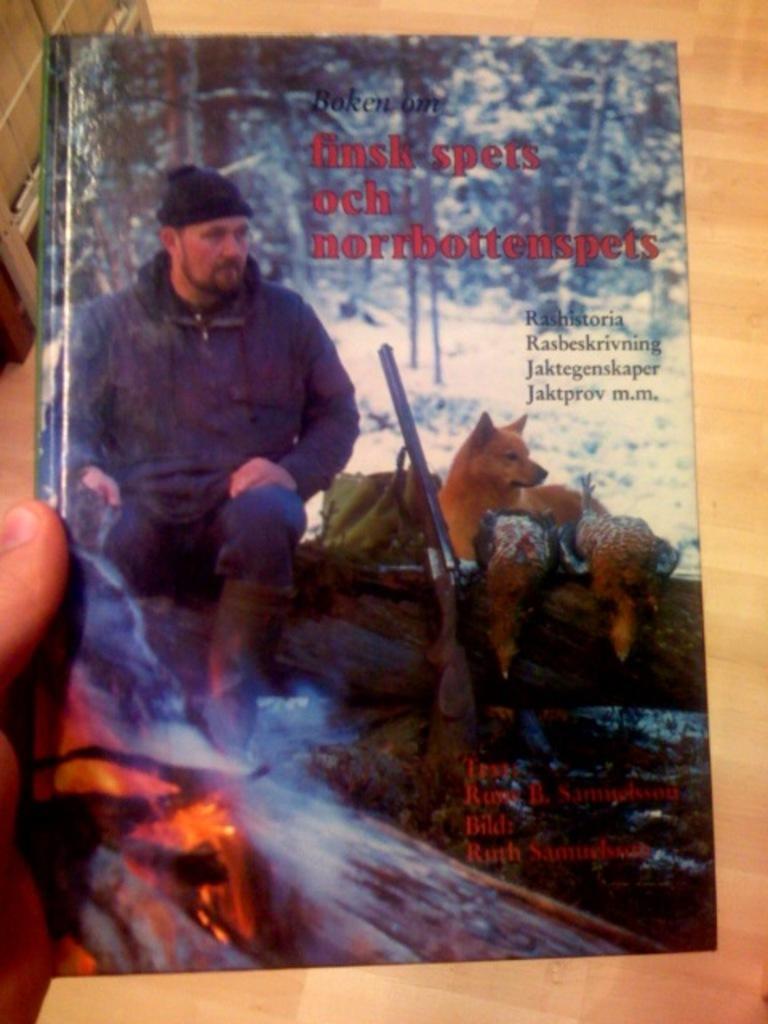Describe this image in one or two sentences. In this image I can see a human hand holding a book. On the cover page of the book I can see a person, few animals, few trees and a gun. I can see the brown colored floor. 